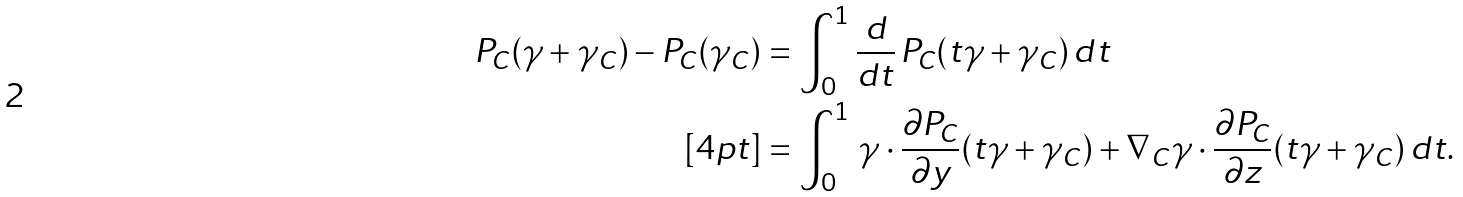Convert formula to latex. <formula><loc_0><loc_0><loc_500><loc_500>P _ { C } ( \gamma + \gamma _ { C } ) - P _ { C } ( \gamma _ { C } ) & = \int _ { 0 } ^ { 1 } \frac { d } { d t } \, P _ { C } ( t \gamma + \gamma _ { C } ) \, d t \\ [ 4 p t ] & = \int _ { 0 } ^ { 1 } \, \gamma \cdot \frac { \partial P _ { C } } { \partial y } ( t \gamma + \gamma _ { C } ) + \nabla _ { C } \gamma \cdot \frac { \partial P _ { C } } { \partial z } ( t \gamma + \gamma _ { C } ) \, d t .</formula> 